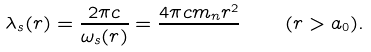Convert formula to latex. <formula><loc_0><loc_0><loc_500><loc_500>\lambda _ { s } ( r ) = \frac { 2 \pi c } { \omega _ { s } ( r ) } = \frac { 4 \pi c m _ { n } r ^ { 2 } } { } \quad ( r > a _ { 0 } ) .</formula> 